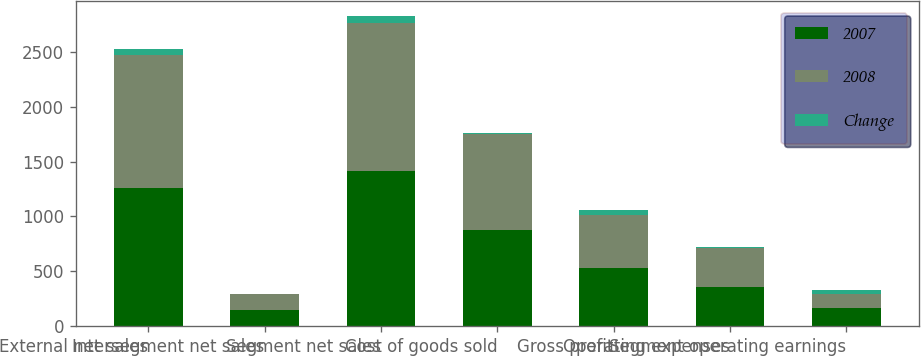<chart> <loc_0><loc_0><loc_500><loc_500><stacked_bar_chart><ecel><fcel>External net sales<fcel>Intersegment net sales<fcel>Segment net sales<fcel>Cost of goods sold<fcel>Gross profit<fcel>Operating expenses<fcel>Segment operating earnings<nl><fcel>2007<fcel>1260.5<fcel>148.8<fcel>1409.3<fcel>878.9<fcel>530.4<fcel>363.1<fcel>167.3<nl><fcel>2008<fcel>1208.6<fcel>142<fcel>1350.6<fcel>867.1<fcel>483.5<fcel>352<fcel>131.5<nl><fcel>Change<fcel>51.9<fcel>6.8<fcel>58.7<fcel>11.8<fcel>46.9<fcel>11.1<fcel>35.8<nl></chart> 